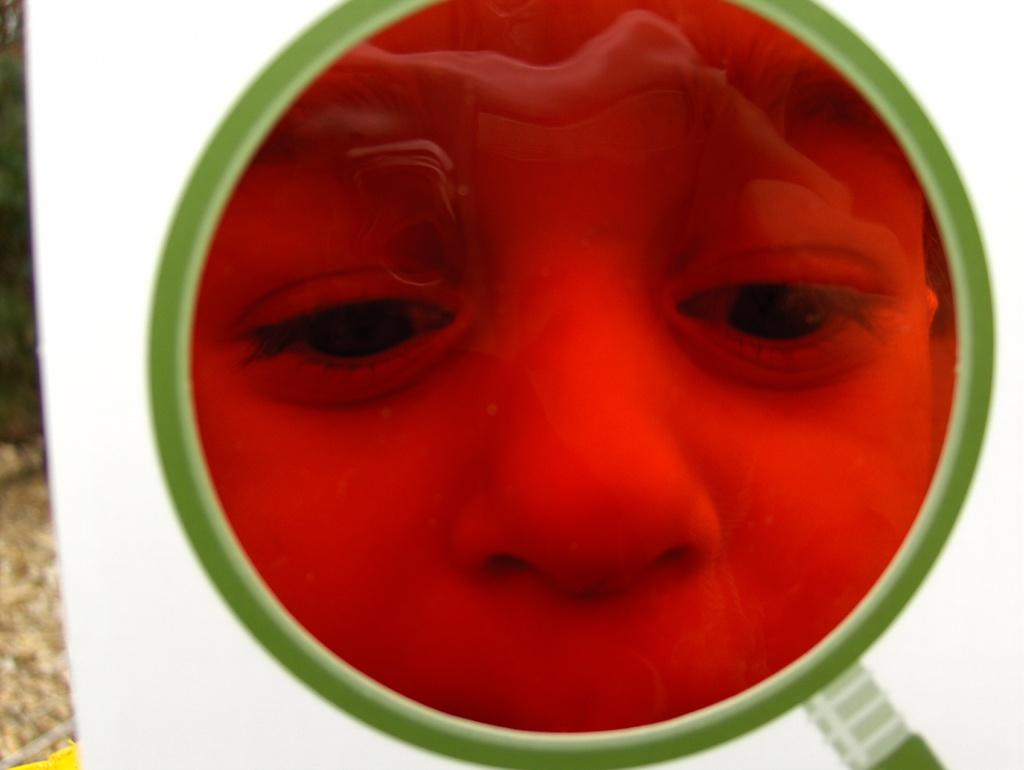What object is the main focus of the image? There is a magnifying glass in the image. What can be seen through the magnifying glass? A person's face is visible through the magnifying glass. How does the background of the image appear? The background of the image is blurry. What type of orange is the actor holding in the image? There is no orange or actor present in the image; it features a magnifying glass and a person's face. How is the hammer being used in the image? There is no hammer present in the image. 